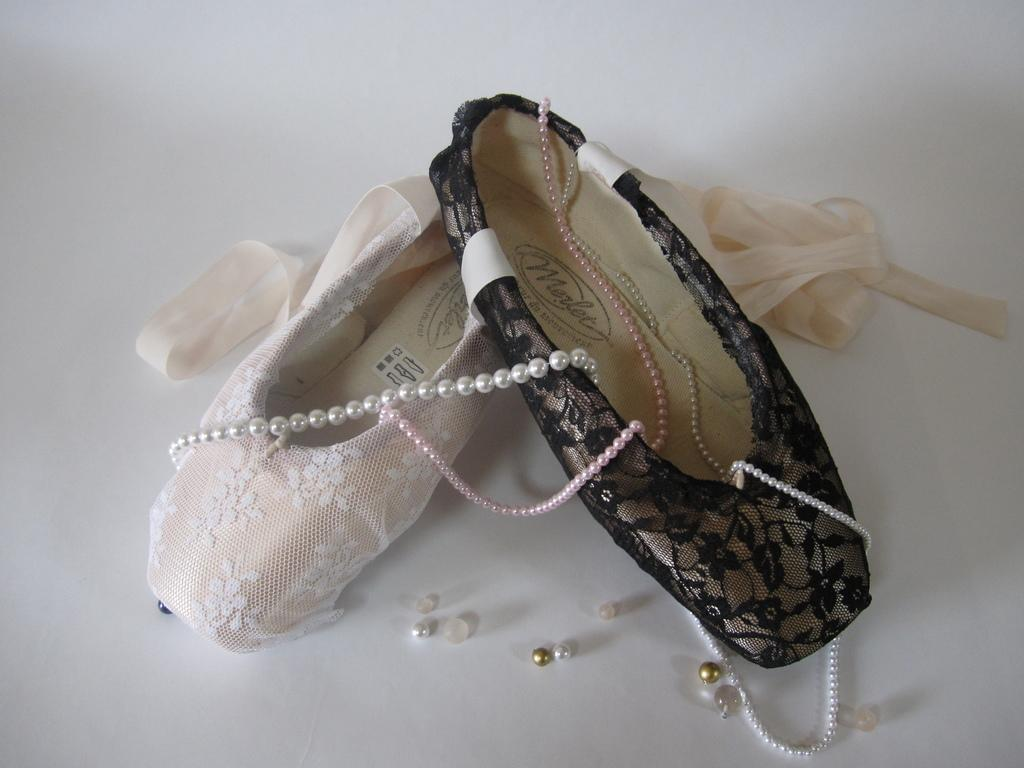What type of footwear is featured in the image? There are two different shoes of a woman in the image. What decorative elements are present on the shoes? The shoes have pearl chains on them. Are there any additional accessories near the shoes? Yes, the shoes have ribbons beside them. Can you see any sailboats on the lake in the image? There is no lake or sailboats present in the image; it features two different shoes of a woman with pearl chains and ribbons. 